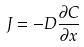<formula> <loc_0><loc_0><loc_500><loc_500>J = - D \frac { \partial C } { \partial x }</formula> 